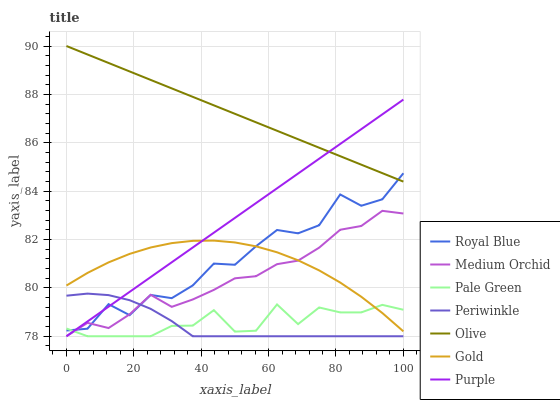Does Periwinkle have the minimum area under the curve?
Answer yes or no. Yes. Does Olive have the maximum area under the curve?
Answer yes or no. Yes. Does Purple have the minimum area under the curve?
Answer yes or no. No. Does Purple have the maximum area under the curve?
Answer yes or no. No. Is Purple the smoothest?
Answer yes or no. Yes. Is Royal Blue the roughest?
Answer yes or no. Yes. Is Medium Orchid the smoothest?
Answer yes or no. No. Is Medium Orchid the roughest?
Answer yes or no. No. Does Royal Blue have the lowest value?
Answer yes or no. No. Does Olive have the highest value?
Answer yes or no. Yes. Does Purple have the highest value?
Answer yes or no. No. Is Gold less than Olive?
Answer yes or no. Yes. Is Olive greater than Periwinkle?
Answer yes or no. Yes. Does Olive intersect Purple?
Answer yes or no. Yes. Is Olive less than Purple?
Answer yes or no. No. Is Olive greater than Purple?
Answer yes or no. No. Does Gold intersect Olive?
Answer yes or no. No. 